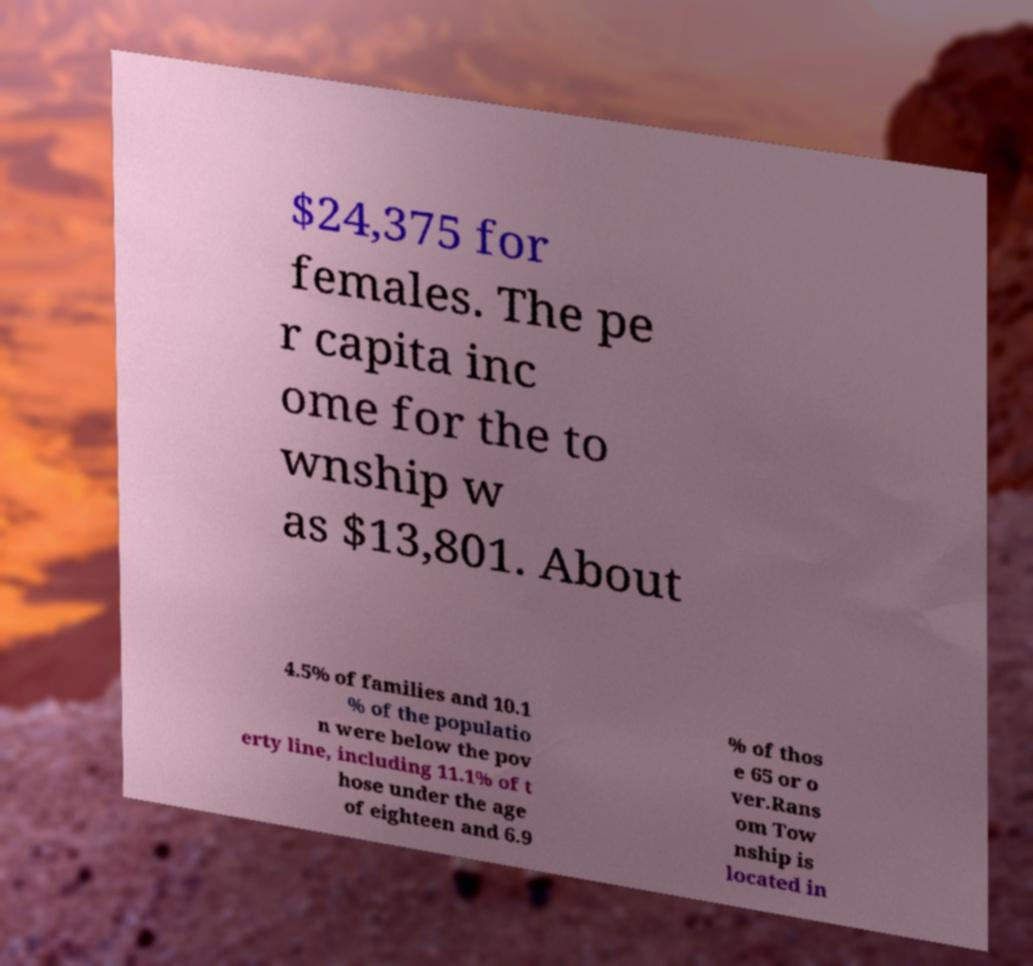Please read and relay the text visible in this image. What does it say? $24,375 for females. The pe r capita inc ome for the to wnship w as $13,801. About 4.5% of families and 10.1 % of the populatio n were below the pov erty line, including 11.1% of t hose under the age of eighteen and 6.9 % of thos e 65 or o ver.Rans om Tow nship is located in 